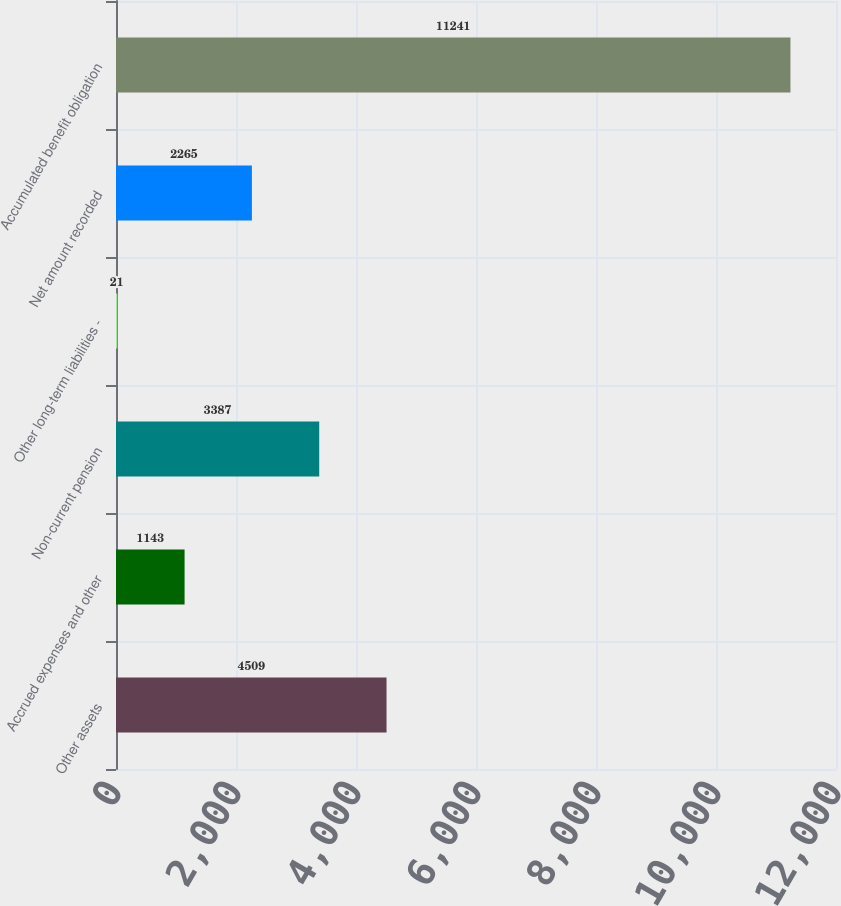Convert chart to OTSL. <chart><loc_0><loc_0><loc_500><loc_500><bar_chart><fcel>Other assets<fcel>Accrued expenses and other<fcel>Non-current pension<fcel>Other long-term liabilities -<fcel>Net amount recorded<fcel>Accumulated benefit obligation<nl><fcel>4509<fcel>1143<fcel>3387<fcel>21<fcel>2265<fcel>11241<nl></chart> 